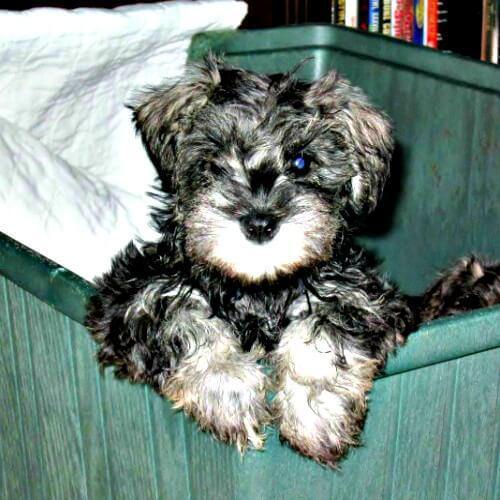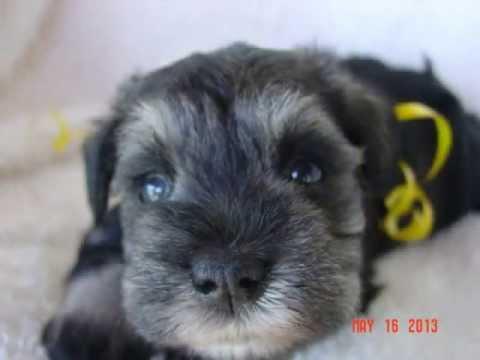The first image is the image on the left, the second image is the image on the right. Given the left and right images, does the statement "The left image shows one schnauzer with its paws propped over and its head poking out of a container, which is draped with something white." hold true? Answer yes or no. Yes. The first image is the image on the left, the second image is the image on the right. For the images shown, is this caption "In one of the images there is a dog on a leash." true? Answer yes or no. No. 